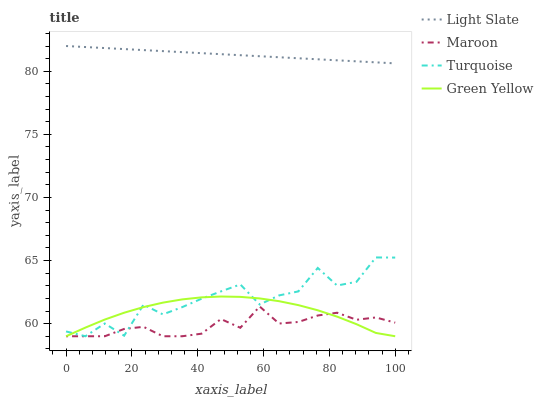Does Maroon have the minimum area under the curve?
Answer yes or no. Yes. Does Light Slate have the maximum area under the curve?
Answer yes or no. Yes. Does Turquoise have the minimum area under the curve?
Answer yes or no. No. Does Turquoise have the maximum area under the curve?
Answer yes or no. No. Is Light Slate the smoothest?
Answer yes or no. Yes. Is Turquoise the roughest?
Answer yes or no. Yes. Is Green Yellow the smoothest?
Answer yes or no. No. Is Green Yellow the roughest?
Answer yes or no. No. Does Turquoise have the lowest value?
Answer yes or no. Yes. Does Light Slate have the highest value?
Answer yes or no. Yes. Does Turquoise have the highest value?
Answer yes or no. No. Is Green Yellow less than Light Slate?
Answer yes or no. Yes. Is Light Slate greater than Maroon?
Answer yes or no. Yes. Does Green Yellow intersect Maroon?
Answer yes or no. Yes. Is Green Yellow less than Maroon?
Answer yes or no. No. Is Green Yellow greater than Maroon?
Answer yes or no. No. Does Green Yellow intersect Light Slate?
Answer yes or no. No. 